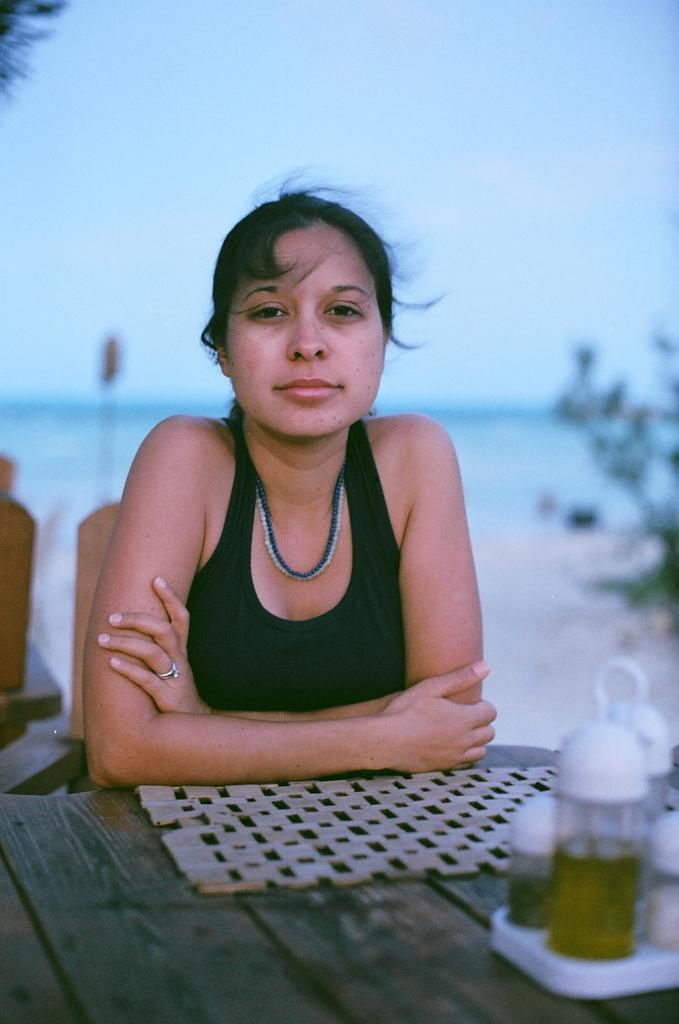In one or two sentences, can you explain what this image depicts? In the center of the image there is a lady sitting on a chair. In front of her there is a table on which there are objects. In the background of the image there is water. To the right side of the image there is a plant. 